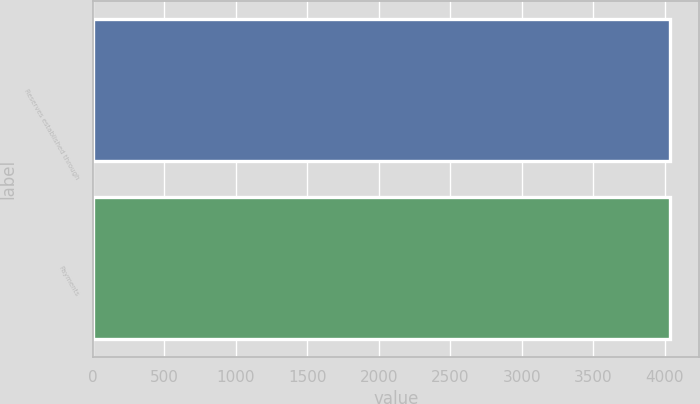Convert chart to OTSL. <chart><loc_0><loc_0><loc_500><loc_500><bar_chart><fcel>Reserves established through<fcel>Payments<nl><fcel>4039<fcel>4039.1<nl></chart> 